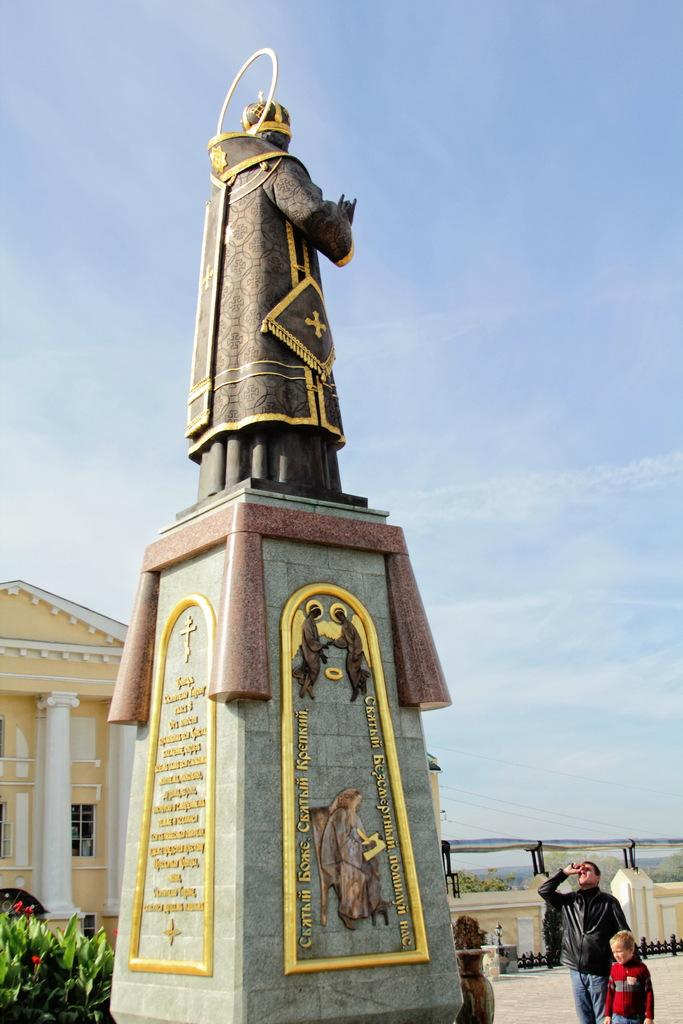What is the main object in the image? There is a statue in the image. What other objects can be seen in the image? There is a plant, a building with windows, and two people standing on the floor. Can you describe the building in the image? The building has pillars and a wall. What is visible in the background of the image? The sky is visible in the background of the image. Where is the park located in the image? There is no park present in the image. What type of food is the person cooking in the image? There is no person cooking in the image. 